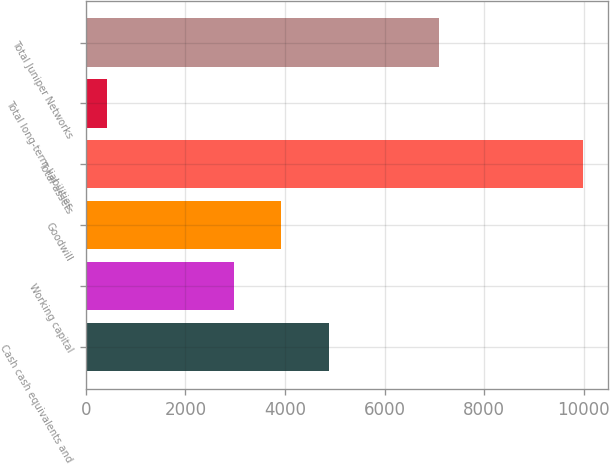Convert chart to OTSL. <chart><loc_0><loc_0><loc_500><loc_500><bar_chart><fcel>Cash cash equivalents and<fcel>Working capital<fcel>Goodwill<fcel>Total assets<fcel>Total long-term liabilities<fcel>Total Juniper Networks<nl><fcel>4884.08<fcel>2973<fcel>3928.54<fcel>9983.8<fcel>428.4<fcel>7089.2<nl></chart> 